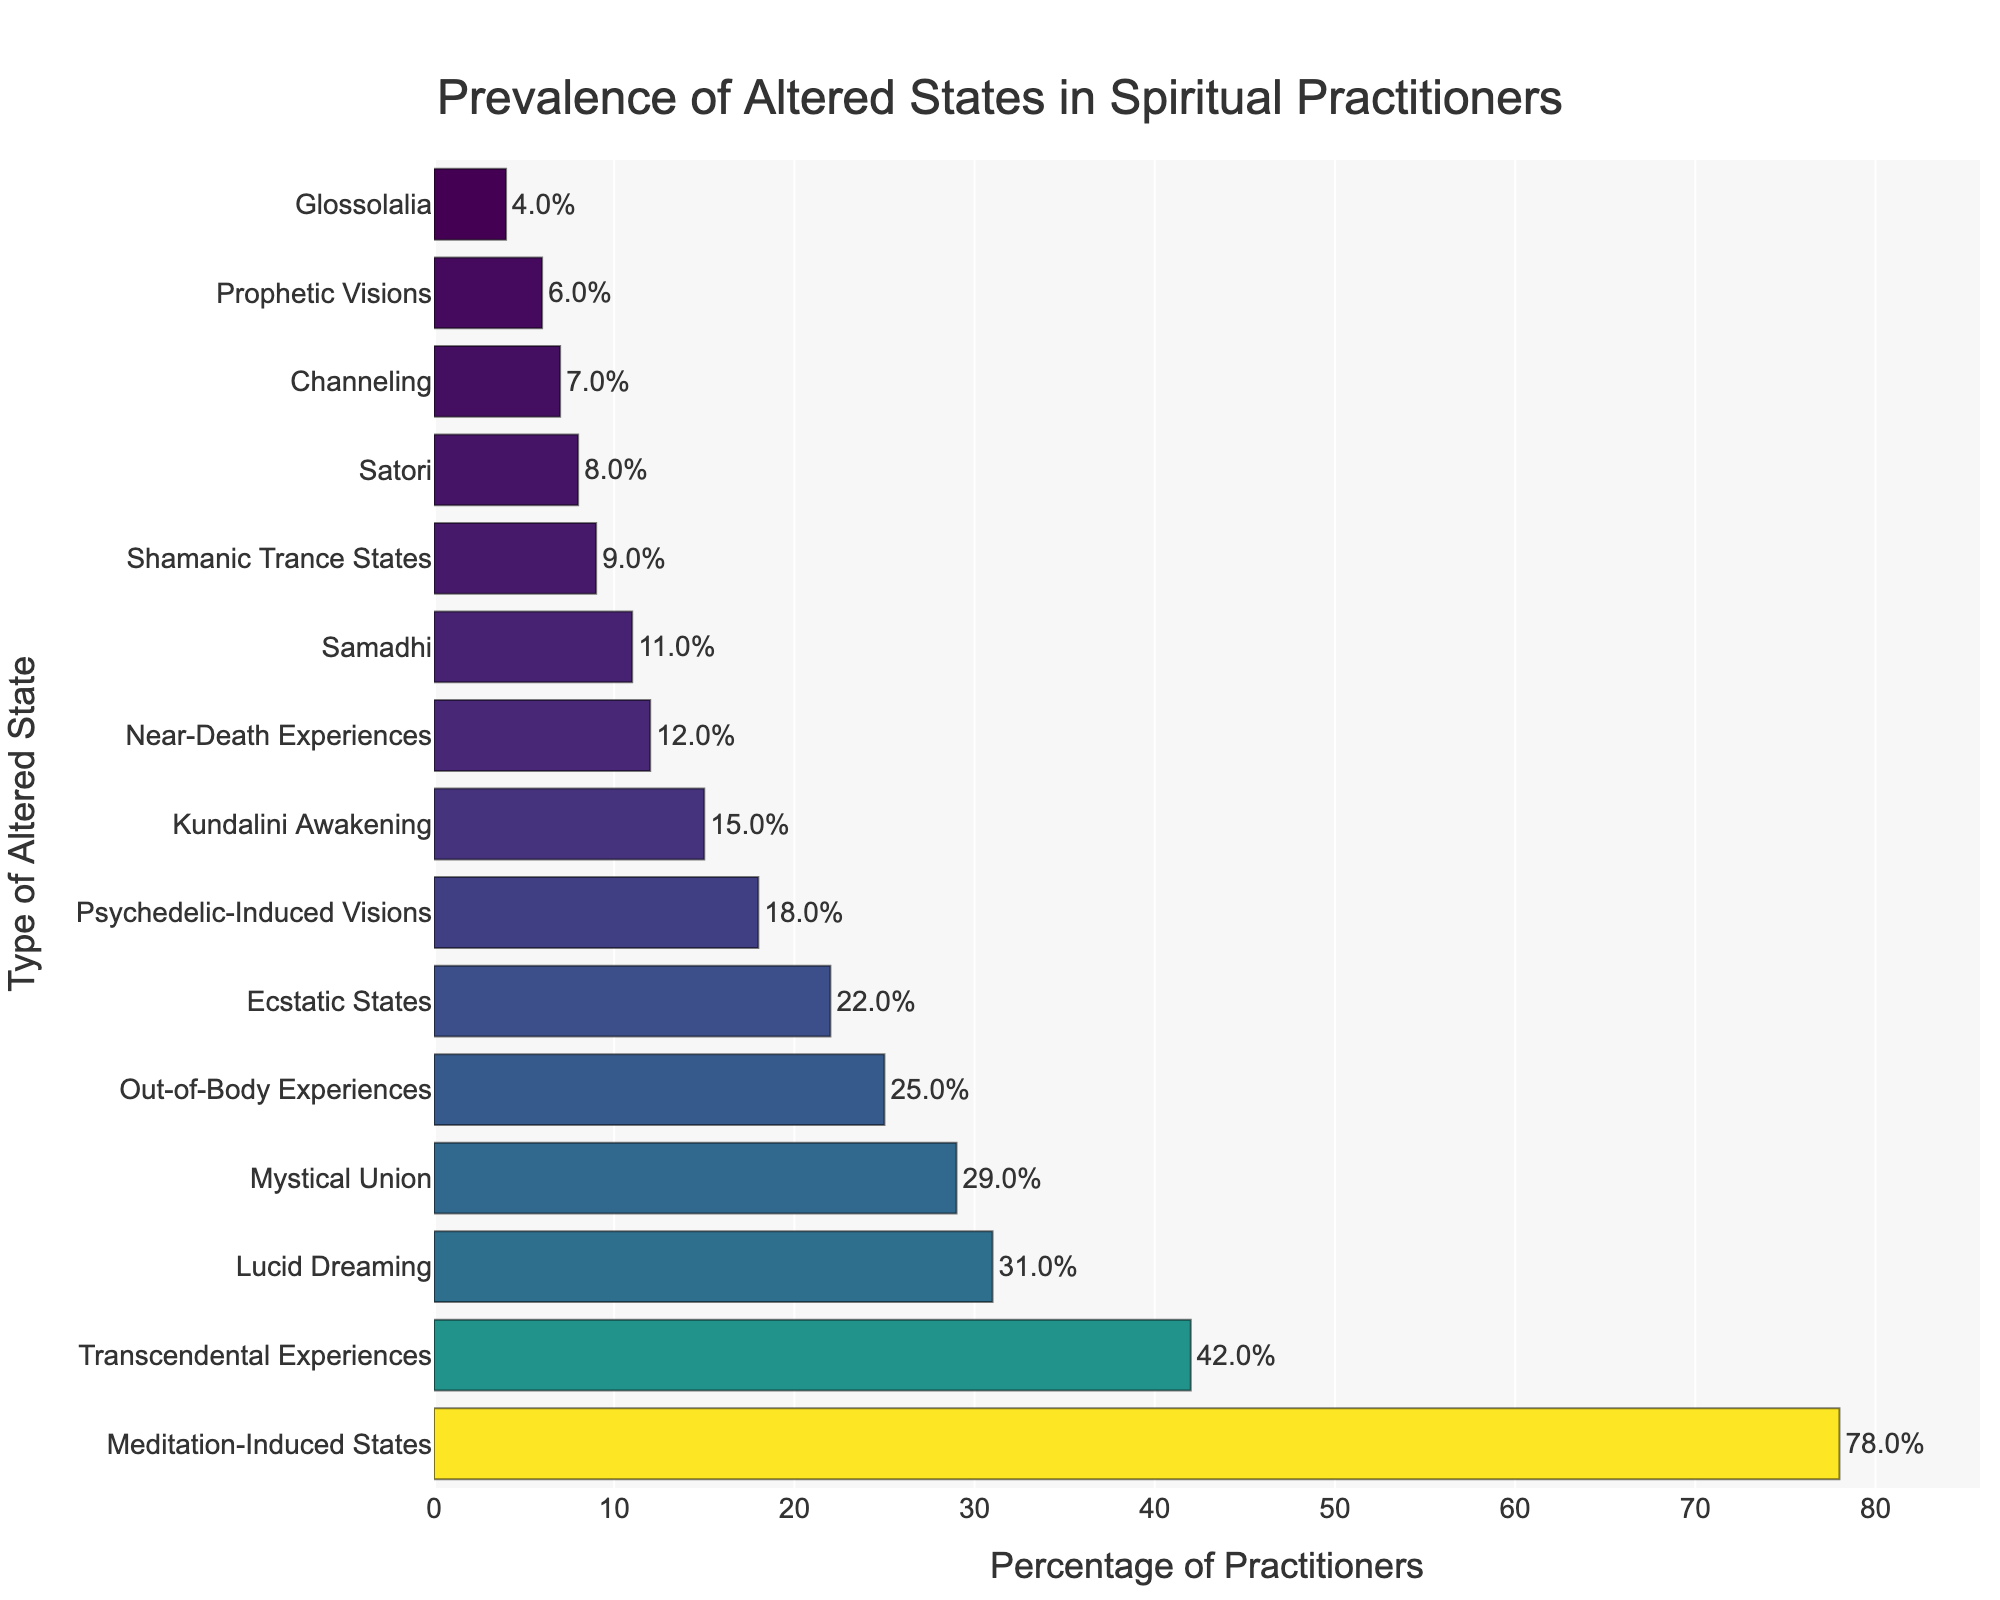Which altered state is experienced by the highest percentage of practitioners? The bar for "Meditation-Induced States" is the longest and positioned at the top of the chart, indicating the highest percentage.
Answer: Meditation-Induced States Which types of altered states have a prevalence of less than 10% among practitioners? By examining the lengths of the bars and their respective labels, the states with percentages less than 10% are Color Channeling, Prophetic Visions, Glossolalia, and Shamanic Trance States.
Answer: Channeling, Prophetic Visions, Glossolalia, Shamanic Trance States What is the difference in prevalence between Lucid Dreaming and Near-Death Experiences? The percentage of practitioners for Lucid Dreaming is 31%, and for Near-Death Experiences, it is 12%. The difference is calculated as 31% - 12% = 19%.
Answer: 19% Which altered states have a prevalence between 10% and 20%? By identifying the bars within this percentage range, the states that fall between 10% and 20% prevalence are Near-Death Experiences, Kundalini Awakening, Psychedelic-Induced Visions, and Shamanic Trance States.
Answer: Near-Death Experiences, Kundalini Awakening, Psychedelic-Induced Visions, Shamanic Trance States How much more prevalent is Mystical Union than Ecstatic States? Mystical Union has a prevalence of 29%, whereas Ecstatic States have a prevalence of 22%. The difference is 29% - 22% = 7%.
Answer: 7% What is the combined prevalence of Samadhi and Satori? The prevalence of Samadhi is 11%, and for Satori, it is 8%. The combined prevalence is 11% + 8% = 19%.
Answer: 19% Is the prevalence of Transcendental Experiences greater than double the prevalence of Kundalini Awakening? The prevalence of Transcendental Experiences is 42%, and for Kundalini Awakening, it is 15%. Double the prevalence of Kundalini Awakening is 15% * 2 = 30%. Since 42% > 30%, the statement is true.
Answer: Yes What altered states have a lower prevalence than Out-of-Body Experiences but higher than Ecstatic States? Out-of-Body Experiences have a prevalence of 25%, and Ecstatic States have a prevalence of 22%. The altered state that falls into this range is Mystical Union, with a prevalence of 29%.
Answer: Mystical Union What is the average prevalence of Lucid Dreaming and Transcendental Experiences? The prevalence of Lucid Dreaming is 31%, and Transcendental Experiences is 42%. The average is calculated as (31% + 42%) / 2 = 36.5%.
Answer: 36.5% Which altered state has the shortest bar on the chart? The shortest bar represents Glossolalia, with a prevalence of 4% of practitioners.
Answer: Glossolalia 